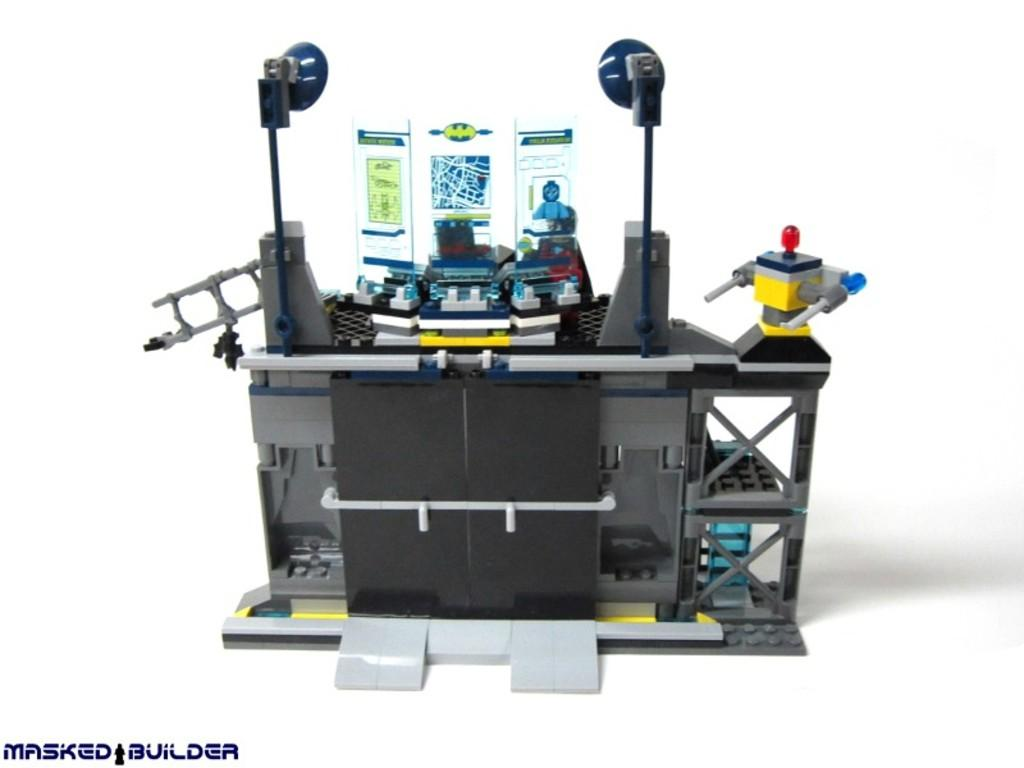What objects are placed on a surface in the image? There are toys placed on a surface in the image. Can you read any text visible at the bottom of the image? Unfortunately, the text visible at the bottom of the image cannot be read in the provided facts. What type of bells can be heard ringing in the image? There are no bells present in the image, and therefore no sound can be heard. 